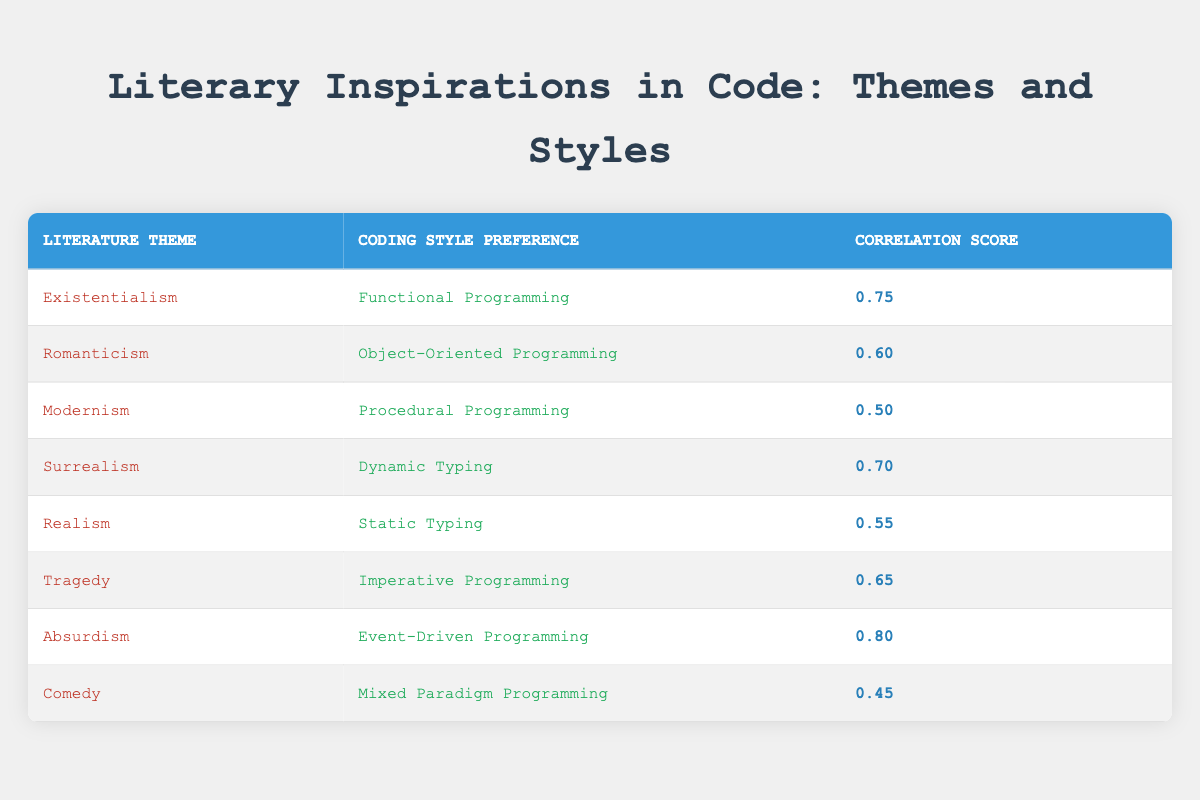What is the highest correlation score in the table? The maximum correlation score among the entries can be found by examining the correlation scores listed. The highest score is 0.80, associated with the theme of Absurdism and Event-Driven Programming.
Answer: 0.80 Which coding style preference is linked with the theme of Realism? To find this, we look for the entry under the Realism theme in the table. It corresponds to the coding style preference of Static Typing.
Answer: Static Typing What is the average correlation score of the coding styles listed? There are 8 correlation scores in total: 0.75, 0.60, 0.50, 0.70, 0.55, 0.65, 0.80, and 0.45. Summing these gives 4.55, and then dividing by 8 (the number of entries) provides an average of 0.56875.
Answer: 0.57 Is there a coding style preference associated with the theme of Comedy? By checking the Comedy theme entry in the table, we see it is associated with Mixed Paradigm Programming. Therefore, the relationship exists.
Answer: Yes Which literature theme has the lowest correlation score? To find this, we need to compare all the correlation scores in the table. The lowest score is 0.45, which is linked to the theme of Comedy and its associated coding style of Mixed Paradigm Programming.
Answer: Comedy 